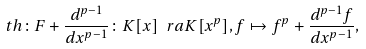Convert formula to latex. <formula><loc_0><loc_0><loc_500><loc_500>\ t h \colon F + \frac { d ^ { p - 1 } } { d x ^ { p - 1 } } \colon K [ x ] \ r a K [ x ^ { p } ] , f \mapsto f ^ { p } + \frac { d ^ { p - 1 } f } { d x ^ { p - 1 } } ,</formula> 